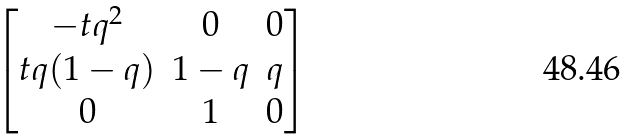<formula> <loc_0><loc_0><loc_500><loc_500>\begin{bmatrix} - t q ^ { 2 } & 0 & 0 \\ t q ( 1 - q ) & 1 - q & q \\ 0 & 1 & 0 \end{bmatrix}</formula> 